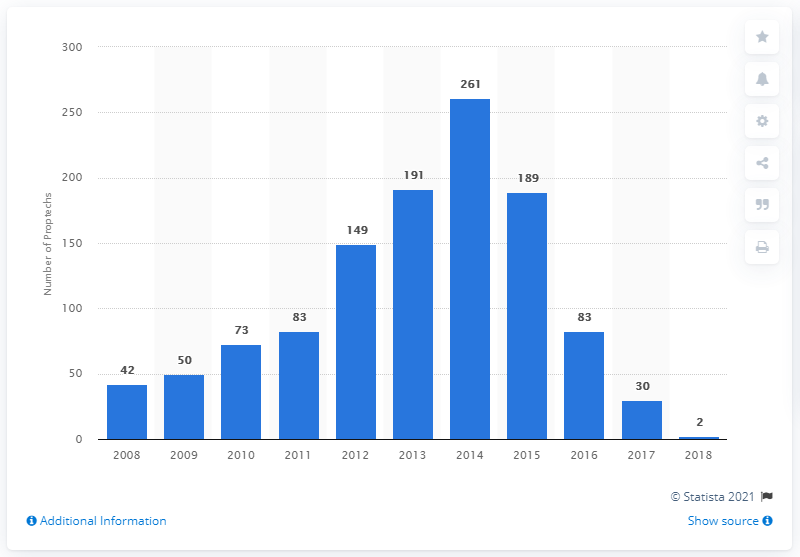Draw attention to some important aspects in this diagram. Since 2014, the number of Proptech companies launched has significantly slowed. In 2014, 261 Proptech companies were launched. 